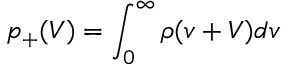<formula> <loc_0><loc_0><loc_500><loc_500>p _ { + } ( V ) = \int _ { 0 } ^ { \infty } \rho ( v + V ) d v</formula> 